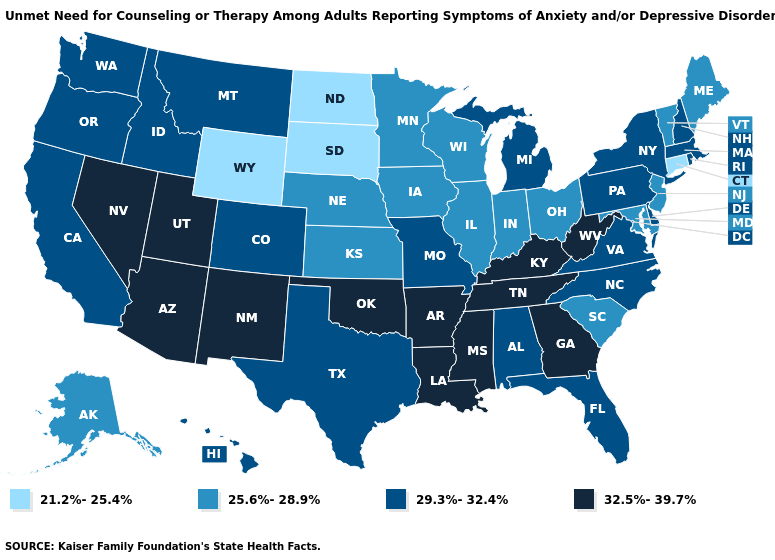What is the value of Alabama?
Be succinct. 29.3%-32.4%. Does Connecticut have the lowest value in the Northeast?
Give a very brief answer. Yes. Name the states that have a value in the range 29.3%-32.4%?
Be succinct. Alabama, California, Colorado, Delaware, Florida, Hawaii, Idaho, Massachusetts, Michigan, Missouri, Montana, New Hampshire, New York, North Carolina, Oregon, Pennsylvania, Rhode Island, Texas, Virginia, Washington. Name the states that have a value in the range 25.6%-28.9%?
Keep it brief. Alaska, Illinois, Indiana, Iowa, Kansas, Maine, Maryland, Minnesota, Nebraska, New Jersey, Ohio, South Carolina, Vermont, Wisconsin. Name the states that have a value in the range 21.2%-25.4%?
Give a very brief answer. Connecticut, North Dakota, South Dakota, Wyoming. Among the states that border New Mexico , which have the lowest value?
Keep it brief. Colorado, Texas. Name the states that have a value in the range 21.2%-25.4%?
Be succinct. Connecticut, North Dakota, South Dakota, Wyoming. Does the first symbol in the legend represent the smallest category?
Write a very short answer. Yes. Among the states that border West Virginia , does Ohio have the lowest value?
Quick response, please. Yes. What is the highest value in the USA?
Quick response, please. 32.5%-39.7%. Does Vermont have the highest value in the Northeast?
Concise answer only. No. What is the lowest value in states that border Arizona?
Short answer required. 29.3%-32.4%. Which states have the lowest value in the South?
Concise answer only. Maryland, South Carolina. Name the states that have a value in the range 32.5%-39.7%?
Quick response, please. Arizona, Arkansas, Georgia, Kentucky, Louisiana, Mississippi, Nevada, New Mexico, Oklahoma, Tennessee, Utah, West Virginia. What is the value of Pennsylvania?
Short answer required. 29.3%-32.4%. 